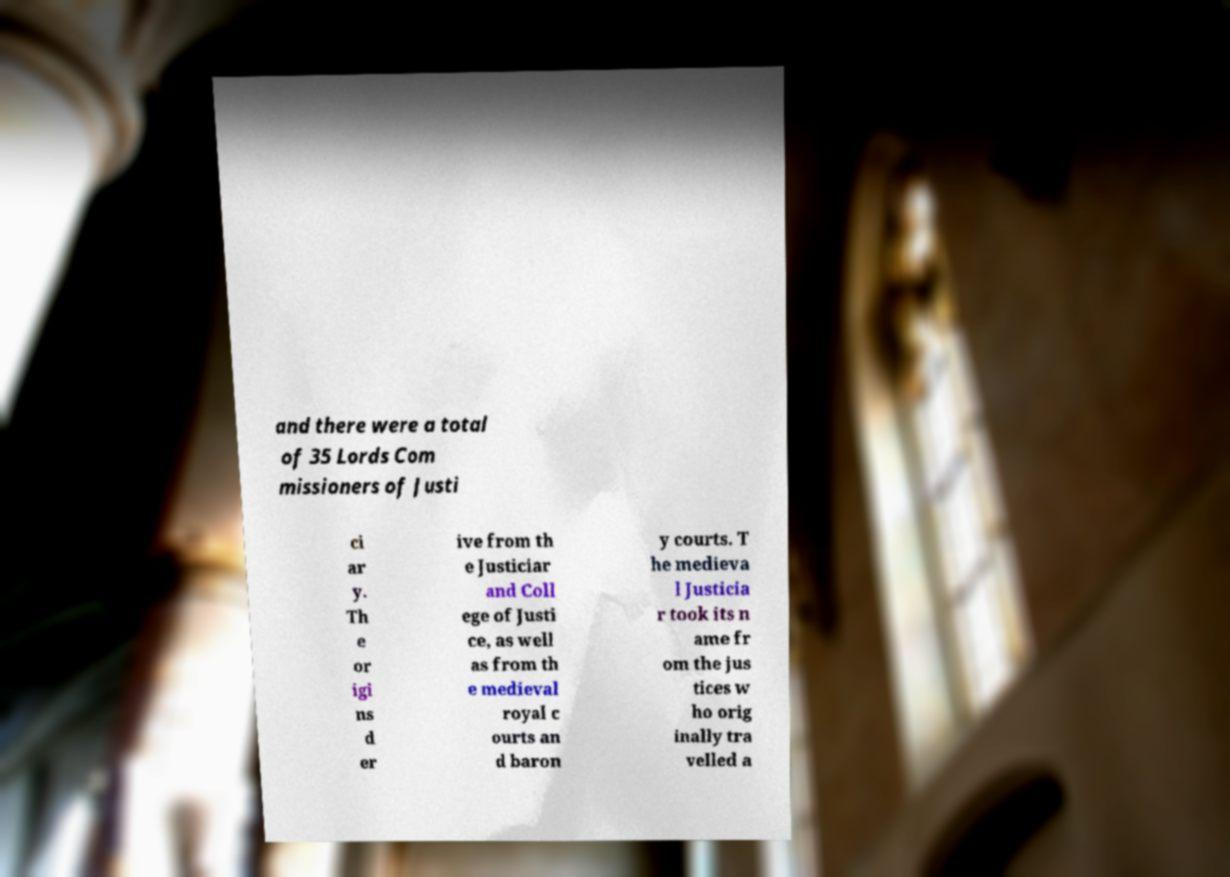Can you read and provide the text displayed in the image?This photo seems to have some interesting text. Can you extract and type it out for me? and there were a total of 35 Lords Com missioners of Justi ci ar y. Th e or igi ns d er ive from th e Justiciar and Coll ege of Justi ce, as well as from th e medieval royal c ourts an d baron y courts. T he medieva l Justicia r took its n ame fr om the jus tices w ho orig inally tra velled a 